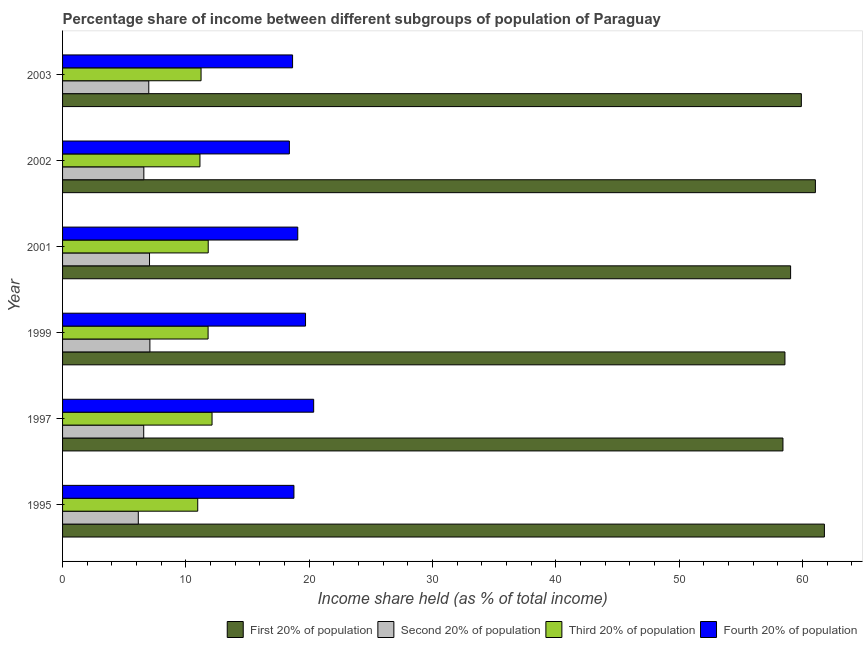How many different coloured bars are there?
Your answer should be compact. 4. Are the number of bars per tick equal to the number of legend labels?
Offer a terse response. Yes. Are the number of bars on each tick of the Y-axis equal?
Keep it short and to the point. Yes. How many bars are there on the 2nd tick from the top?
Provide a succinct answer. 4. What is the label of the 6th group of bars from the top?
Offer a very short reply. 1995. In how many cases, is the number of bars for a given year not equal to the number of legend labels?
Offer a terse response. 0. What is the share of the income held by fourth 20% of the population in 1995?
Your response must be concise. 18.76. Across all years, what is the maximum share of the income held by first 20% of the population?
Your response must be concise. 61.77. Across all years, what is the minimum share of the income held by fourth 20% of the population?
Your answer should be very brief. 18.39. In which year was the share of the income held by second 20% of the population minimum?
Your response must be concise. 1995. What is the total share of the income held by fourth 20% of the population in the graph?
Offer a very short reply. 114.93. What is the difference between the share of the income held by third 20% of the population in 1997 and that in 2001?
Make the answer very short. 0.31. What is the difference between the share of the income held by second 20% of the population in 2002 and the share of the income held by third 20% of the population in 2001?
Keep it short and to the point. -5.22. What is the average share of the income held by third 20% of the population per year?
Keep it short and to the point. 11.51. In the year 1997, what is the difference between the share of the income held by second 20% of the population and share of the income held by fourth 20% of the population?
Keep it short and to the point. -13.78. In how many years, is the share of the income held by second 20% of the population greater than 4 %?
Offer a very short reply. 6. What is the ratio of the share of the income held by third 20% of the population in 1999 to that in 2003?
Your answer should be compact. 1.05. Is the share of the income held by second 20% of the population in 2002 less than that in 2003?
Your response must be concise. Yes. What is the difference between the highest and the second highest share of the income held by first 20% of the population?
Keep it short and to the point. 0.73. What is the difference between the highest and the lowest share of the income held by third 20% of the population?
Your answer should be very brief. 1.16. In how many years, is the share of the income held by first 20% of the population greater than the average share of the income held by first 20% of the population taken over all years?
Your answer should be very brief. 3. What does the 1st bar from the top in 2002 represents?
Offer a terse response. Fourth 20% of population. What does the 3rd bar from the bottom in 1999 represents?
Keep it short and to the point. Third 20% of population. Is it the case that in every year, the sum of the share of the income held by first 20% of the population and share of the income held by second 20% of the population is greater than the share of the income held by third 20% of the population?
Make the answer very short. Yes. How many bars are there?
Give a very brief answer. 24. Are all the bars in the graph horizontal?
Your response must be concise. Yes. What is the difference between two consecutive major ticks on the X-axis?
Your response must be concise. 10. Where does the legend appear in the graph?
Ensure brevity in your answer.  Bottom right. How many legend labels are there?
Ensure brevity in your answer.  4. How are the legend labels stacked?
Provide a succinct answer. Horizontal. What is the title of the graph?
Provide a succinct answer. Percentage share of income between different subgroups of population of Paraguay. What is the label or title of the X-axis?
Your response must be concise. Income share held (as % of total income). What is the Income share held (as % of total income) in First 20% of population in 1995?
Your response must be concise. 61.77. What is the Income share held (as % of total income) of Second 20% of population in 1995?
Keep it short and to the point. 6.14. What is the Income share held (as % of total income) of Third 20% of population in 1995?
Your answer should be compact. 10.96. What is the Income share held (as % of total income) in Fourth 20% of population in 1995?
Your answer should be compact. 18.76. What is the Income share held (as % of total income) of First 20% of population in 1997?
Your answer should be very brief. 58.41. What is the Income share held (as % of total income) of Second 20% of population in 1997?
Your response must be concise. 6.58. What is the Income share held (as % of total income) in Third 20% of population in 1997?
Keep it short and to the point. 12.12. What is the Income share held (as % of total income) in Fourth 20% of population in 1997?
Provide a succinct answer. 20.36. What is the Income share held (as % of total income) of First 20% of population in 1999?
Provide a succinct answer. 58.57. What is the Income share held (as % of total income) of Second 20% of population in 1999?
Keep it short and to the point. 7.08. What is the Income share held (as % of total income) in First 20% of population in 2001?
Your answer should be compact. 59.03. What is the Income share held (as % of total income) of Second 20% of population in 2001?
Your answer should be very brief. 7.05. What is the Income share held (as % of total income) in Third 20% of population in 2001?
Provide a succinct answer. 11.81. What is the Income share held (as % of total income) in Fourth 20% of population in 2001?
Keep it short and to the point. 19.07. What is the Income share held (as % of total income) of First 20% of population in 2002?
Make the answer very short. 61.04. What is the Income share held (as % of total income) of Second 20% of population in 2002?
Your answer should be very brief. 6.59. What is the Income share held (as % of total income) in Third 20% of population in 2002?
Ensure brevity in your answer.  11.14. What is the Income share held (as % of total income) in Fourth 20% of population in 2002?
Give a very brief answer. 18.39. What is the Income share held (as % of total income) in First 20% of population in 2003?
Provide a succinct answer. 59.9. What is the Income share held (as % of total income) in Second 20% of population in 2003?
Keep it short and to the point. 6.99. What is the Income share held (as % of total income) of Third 20% of population in 2003?
Your answer should be very brief. 11.23. What is the Income share held (as % of total income) in Fourth 20% of population in 2003?
Keep it short and to the point. 18.65. Across all years, what is the maximum Income share held (as % of total income) of First 20% of population?
Ensure brevity in your answer.  61.77. Across all years, what is the maximum Income share held (as % of total income) of Second 20% of population?
Your answer should be compact. 7.08. Across all years, what is the maximum Income share held (as % of total income) of Third 20% of population?
Your answer should be very brief. 12.12. Across all years, what is the maximum Income share held (as % of total income) of Fourth 20% of population?
Offer a very short reply. 20.36. Across all years, what is the minimum Income share held (as % of total income) of First 20% of population?
Make the answer very short. 58.41. Across all years, what is the minimum Income share held (as % of total income) of Second 20% of population?
Your answer should be very brief. 6.14. Across all years, what is the minimum Income share held (as % of total income) in Third 20% of population?
Provide a succinct answer. 10.96. Across all years, what is the minimum Income share held (as % of total income) in Fourth 20% of population?
Your response must be concise. 18.39. What is the total Income share held (as % of total income) in First 20% of population in the graph?
Provide a succinct answer. 358.72. What is the total Income share held (as % of total income) of Second 20% of population in the graph?
Your answer should be very brief. 40.43. What is the total Income share held (as % of total income) in Third 20% of population in the graph?
Make the answer very short. 69.06. What is the total Income share held (as % of total income) of Fourth 20% of population in the graph?
Keep it short and to the point. 114.93. What is the difference between the Income share held (as % of total income) in First 20% of population in 1995 and that in 1997?
Provide a short and direct response. 3.36. What is the difference between the Income share held (as % of total income) of Second 20% of population in 1995 and that in 1997?
Ensure brevity in your answer.  -0.44. What is the difference between the Income share held (as % of total income) of Third 20% of population in 1995 and that in 1997?
Keep it short and to the point. -1.16. What is the difference between the Income share held (as % of total income) of First 20% of population in 1995 and that in 1999?
Offer a very short reply. 3.2. What is the difference between the Income share held (as % of total income) in Second 20% of population in 1995 and that in 1999?
Provide a succinct answer. -0.94. What is the difference between the Income share held (as % of total income) of Third 20% of population in 1995 and that in 1999?
Ensure brevity in your answer.  -0.84. What is the difference between the Income share held (as % of total income) in Fourth 20% of population in 1995 and that in 1999?
Your answer should be compact. -0.94. What is the difference between the Income share held (as % of total income) of First 20% of population in 1995 and that in 2001?
Offer a terse response. 2.74. What is the difference between the Income share held (as % of total income) in Second 20% of population in 1995 and that in 2001?
Keep it short and to the point. -0.91. What is the difference between the Income share held (as % of total income) of Third 20% of population in 1995 and that in 2001?
Your response must be concise. -0.85. What is the difference between the Income share held (as % of total income) of Fourth 20% of population in 1995 and that in 2001?
Offer a terse response. -0.31. What is the difference between the Income share held (as % of total income) of First 20% of population in 1995 and that in 2002?
Offer a very short reply. 0.73. What is the difference between the Income share held (as % of total income) of Second 20% of population in 1995 and that in 2002?
Offer a terse response. -0.45. What is the difference between the Income share held (as % of total income) of Third 20% of population in 1995 and that in 2002?
Make the answer very short. -0.18. What is the difference between the Income share held (as % of total income) in Fourth 20% of population in 1995 and that in 2002?
Keep it short and to the point. 0.37. What is the difference between the Income share held (as % of total income) of First 20% of population in 1995 and that in 2003?
Provide a succinct answer. 1.87. What is the difference between the Income share held (as % of total income) of Second 20% of population in 1995 and that in 2003?
Offer a terse response. -0.85. What is the difference between the Income share held (as % of total income) in Third 20% of population in 1995 and that in 2003?
Offer a very short reply. -0.27. What is the difference between the Income share held (as % of total income) in Fourth 20% of population in 1995 and that in 2003?
Your response must be concise. 0.11. What is the difference between the Income share held (as % of total income) of First 20% of population in 1997 and that in 1999?
Keep it short and to the point. -0.16. What is the difference between the Income share held (as % of total income) of Third 20% of population in 1997 and that in 1999?
Your response must be concise. 0.32. What is the difference between the Income share held (as % of total income) of Fourth 20% of population in 1997 and that in 1999?
Ensure brevity in your answer.  0.66. What is the difference between the Income share held (as % of total income) of First 20% of population in 1997 and that in 2001?
Your answer should be very brief. -0.62. What is the difference between the Income share held (as % of total income) of Second 20% of population in 1997 and that in 2001?
Keep it short and to the point. -0.47. What is the difference between the Income share held (as % of total income) in Third 20% of population in 1997 and that in 2001?
Your response must be concise. 0.31. What is the difference between the Income share held (as % of total income) of Fourth 20% of population in 1997 and that in 2001?
Provide a short and direct response. 1.29. What is the difference between the Income share held (as % of total income) of First 20% of population in 1997 and that in 2002?
Provide a succinct answer. -2.63. What is the difference between the Income share held (as % of total income) in Second 20% of population in 1997 and that in 2002?
Your answer should be compact. -0.01. What is the difference between the Income share held (as % of total income) in Third 20% of population in 1997 and that in 2002?
Offer a terse response. 0.98. What is the difference between the Income share held (as % of total income) in Fourth 20% of population in 1997 and that in 2002?
Offer a terse response. 1.97. What is the difference between the Income share held (as % of total income) in First 20% of population in 1997 and that in 2003?
Your response must be concise. -1.49. What is the difference between the Income share held (as % of total income) of Second 20% of population in 1997 and that in 2003?
Provide a succinct answer. -0.41. What is the difference between the Income share held (as % of total income) in Third 20% of population in 1997 and that in 2003?
Ensure brevity in your answer.  0.89. What is the difference between the Income share held (as % of total income) in Fourth 20% of population in 1997 and that in 2003?
Offer a terse response. 1.71. What is the difference between the Income share held (as % of total income) in First 20% of population in 1999 and that in 2001?
Your answer should be very brief. -0.46. What is the difference between the Income share held (as % of total income) in Third 20% of population in 1999 and that in 2001?
Your answer should be very brief. -0.01. What is the difference between the Income share held (as % of total income) in Fourth 20% of population in 1999 and that in 2001?
Your answer should be very brief. 0.63. What is the difference between the Income share held (as % of total income) in First 20% of population in 1999 and that in 2002?
Your answer should be very brief. -2.47. What is the difference between the Income share held (as % of total income) in Second 20% of population in 1999 and that in 2002?
Ensure brevity in your answer.  0.49. What is the difference between the Income share held (as % of total income) of Third 20% of population in 1999 and that in 2002?
Offer a very short reply. 0.66. What is the difference between the Income share held (as % of total income) in Fourth 20% of population in 1999 and that in 2002?
Your answer should be very brief. 1.31. What is the difference between the Income share held (as % of total income) in First 20% of population in 1999 and that in 2003?
Offer a very short reply. -1.33. What is the difference between the Income share held (as % of total income) in Second 20% of population in 1999 and that in 2003?
Provide a succinct answer. 0.09. What is the difference between the Income share held (as % of total income) in Third 20% of population in 1999 and that in 2003?
Provide a short and direct response. 0.57. What is the difference between the Income share held (as % of total income) in Fourth 20% of population in 1999 and that in 2003?
Ensure brevity in your answer.  1.05. What is the difference between the Income share held (as % of total income) in First 20% of population in 2001 and that in 2002?
Your answer should be very brief. -2.01. What is the difference between the Income share held (as % of total income) in Second 20% of population in 2001 and that in 2002?
Ensure brevity in your answer.  0.46. What is the difference between the Income share held (as % of total income) of Third 20% of population in 2001 and that in 2002?
Your answer should be compact. 0.67. What is the difference between the Income share held (as % of total income) of Fourth 20% of population in 2001 and that in 2002?
Provide a short and direct response. 0.68. What is the difference between the Income share held (as % of total income) of First 20% of population in 2001 and that in 2003?
Ensure brevity in your answer.  -0.87. What is the difference between the Income share held (as % of total income) in Second 20% of population in 2001 and that in 2003?
Keep it short and to the point. 0.06. What is the difference between the Income share held (as % of total income) of Third 20% of population in 2001 and that in 2003?
Your answer should be compact. 0.58. What is the difference between the Income share held (as % of total income) in Fourth 20% of population in 2001 and that in 2003?
Give a very brief answer. 0.42. What is the difference between the Income share held (as % of total income) in First 20% of population in 2002 and that in 2003?
Keep it short and to the point. 1.14. What is the difference between the Income share held (as % of total income) in Third 20% of population in 2002 and that in 2003?
Offer a terse response. -0.09. What is the difference between the Income share held (as % of total income) of Fourth 20% of population in 2002 and that in 2003?
Your answer should be very brief. -0.26. What is the difference between the Income share held (as % of total income) in First 20% of population in 1995 and the Income share held (as % of total income) in Second 20% of population in 1997?
Ensure brevity in your answer.  55.19. What is the difference between the Income share held (as % of total income) in First 20% of population in 1995 and the Income share held (as % of total income) in Third 20% of population in 1997?
Ensure brevity in your answer.  49.65. What is the difference between the Income share held (as % of total income) in First 20% of population in 1995 and the Income share held (as % of total income) in Fourth 20% of population in 1997?
Provide a short and direct response. 41.41. What is the difference between the Income share held (as % of total income) in Second 20% of population in 1995 and the Income share held (as % of total income) in Third 20% of population in 1997?
Offer a very short reply. -5.98. What is the difference between the Income share held (as % of total income) in Second 20% of population in 1995 and the Income share held (as % of total income) in Fourth 20% of population in 1997?
Provide a short and direct response. -14.22. What is the difference between the Income share held (as % of total income) in Third 20% of population in 1995 and the Income share held (as % of total income) in Fourth 20% of population in 1997?
Keep it short and to the point. -9.4. What is the difference between the Income share held (as % of total income) in First 20% of population in 1995 and the Income share held (as % of total income) in Second 20% of population in 1999?
Offer a terse response. 54.69. What is the difference between the Income share held (as % of total income) in First 20% of population in 1995 and the Income share held (as % of total income) in Third 20% of population in 1999?
Your response must be concise. 49.97. What is the difference between the Income share held (as % of total income) of First 20% of population in 1995 and the Income share held (as % of total income) of Fourth 20% of population in 1999?
Your answer should be very brief. 42.07. What is the difference between the Income share held (as % of total income) of Second 20% of population in 1995 and the Income share held (as % of total income) of Third 20% of population in 1999?
Keep it short and to the point. -5.66. What is the difference between the Income share held (as % of total income) in Second 20% of population in 1995 and the Income share held (as % of total income) in Fourth 20% of population in 1999?
Your answer should be compact. -13.56. What is the difference between the Income share held (as % of total income) of Third 20% of population in 1995 and the Income share held (as % of total income) of Fourth 20% of population in 1999?
Give a very brief answer. -8.74. What is the difference between the Income share held (as % of total income) in First 20% of population in 1995 and the Income share held (as % of total income) in Second 20% of population in 2001?
Your answer should be compact. 54.72. What is the difference between the Income share held (as % of total income) of First 20% of population in 1995 and the Income share held (as % of total income) of Third 20% of population in 2001?
Provide a succinct answer. 49.96. What is the difference between the Income share held (as % of total income) of First 20% of population in 1995 and the Income share held (as % of total income) of Fourth 20% of population in 2001?
Your answer should be very brief. 42.7. What is the difference between the Income share held (as % of total income) of Second 20% of population in 1995 and the Income share held (as % of total income) of Third 20% of population in 2001?
Your answer should be very brief. -5.67. What is the difference between the Income share held (as % of total income) in Second 20% of population in 1995 and the Income share held (as % of total income) in Fourth 20% of population in 2001?
Offer a terse response. -12.93. What is the difference between the Income share held (as % of total income) of Third 20% of population in 1995 and the Income share held (as % of total income) of Fourth 20% of population in 2001?
Give a very brief answer. -8.11. What is the difference between the Income share held (as % of total income) of First 20% of population in 1995 and the Income share held (as % of total income) of Second 20% of population in 2002?
Offer a terse response. 55.18. What is the difference between the Income share held (as % of total income) of First 20% of population in 1995 and the Income share held (as % of total income) of Third 20% of population in 2002?
Provide a short and direct response. 50.63. What is the difference between the Income share held (as % of total income) in First 20% of population in 1995 and the Income share held (as % of total income) in Fourth 20% of population in 2002?
Your answer should be very brief. 43.38. What is the difference between the Income share held (as % of total income) of Second 20% of population in 1995 and the Income share held (as % of total income) of Fourth 20% of population in 2002?
Make the answer very short. -12.25. What is the difference between the Income share held (as % of total income) in Third 20% of population in 1995 and the Income share held (as % of total income) in Fourth 20% of population in 2002?
Ensure brevity in your answer.  -7.43. What is the difference between the Income share held (as % of total income) of First 20% of population in 1995 and the Income share held (as % of total income) of Second 20% of population in 2003?
Provide a short and direct response. 54.78. What is the difference between the Income share held (as % of total income) in First 20% of population in 1995 and the Income share held (as % of total income) in Third 20% of population in 2003?
Your answer should be compact. 50.54. What is the difference between the Income share held (as % of total income) of First 20% of population in 1995 and the Income share held (as % of total income) of Fourth 20% of population in 2003?
Keep it short and to the point. 43.12. What is the difference between the Income share held (as % of total income) of Second 20% of population in 1995 and the Income share held (as % of total income) of Third 20% of population in 2003?
Make the answer very short. -5.09. What is the difference between the Income share held (as % of total income) of Second 20% of population in 1995 and the Income share held (as % of total income) of Fourth 20% of population in 2003?
Give a very brief answer. -12.51. What is the difference between the Income share held (as % of total income) in Third 20% of population in 1995 and the Income share held (as % of total income) in Fourth 20% of population in 2003?
Offer a very short reply. -7.69. What is the difference between the Income share held (as % of total income) of First 20% of population in 1997 and the Income share held (as % of total income) of Second 20% of population in 1999?
Offer a terse response. 51.33. What is the difference between the Income share held (as % of total income) of First 20% of population in 1997 and the Income share held (as % of total income) of Third 20% of population in 1999?
Keep it short and to the point. 46.61. What is the difference between the Income share held (as % of total income) of First 20% of population in 1997 and the Income share held (as % of total income) of Fourth 20% of population in 1999?
Keep it short and to the point. 38.71. What is the difference between the Income share held (as % of total income) of Second 20% of population in 1997 and the Income share held (as % of total income) of Third 20% of population in 1999?
Your response must be concise. -5.22. What is the difference between the Income share held (as % of total income) in Second 20% of population in 1997 and the Income share held (as % of total income) in Fourth 20% of population in 1999?
Offer a very short reply. -13.12. What is the difference between the Income share held (as % of total income) in Third 20% of population in 1997 and the Income share held (as % of total income) in Fourth 20% of population in 1999?
Make the answer very short. -7.58. What is the difference between the Income share held (as % of total income) in First 20% of population in 1997 and the Income share held (as % of total income) in Second 20% of population in 2001?
Ensure brevity in your answer.  51.36. What is the difference between the Income share held (as % of total income) of First 20% of population in 1997 and the Income share held (as % of total income) of Third 20% of population in 2001?
Provide a short and direct response. 46.6. What is the difference between the Income share held (as % of total income) of First 20% of population in 1997 and the Income share held (as % of total income) of Fourth 20% of population in 2001?
Provide a short and direct response. 39.34. What is the difference between the Income share held (as % of total income) of Second 20% of population in 1997 and the Income share held (as % of total income) of Third 20% of population in 2001?
Keep it short and to the point. -5.23. What is the difference between the Income share held (as % of total income) in Second 20% of population in 1997 and the Income share held (as % of total income) in Fourth 20% of population in 2001?
Offer a very short reply. -12.49. What is the difference between the Income share held (as % of total income) of Third 20% of population in 1997 and the Income share held (as % of total income) of Fourth 20% of population in 2001?
Make the answer very short. -6.95. What is the difference between the Income share held (as % of total income) of First 20% of population in 1997 and the Income share held (as % of total income) of Second 20% of population in 2002?
Keep it short and to the point. 51.82. What is the difference between the Income share held (as % of total income) in First 20% of population in 1997 and the Income share held (as % of total income) in Third 20% of population in 2002?
Make the answer very short. 47.27. What is the difference between the Income share held (as % of total income) of First 20% of population in 1997 and the Income share held (as % of total income) of Fourth 20% of population in 2002?
Offer a terse response. 40.02. What is the difference between the Income share held (as % of total income) in Second 20% of population in 1997 and the Income share held (as % of total income) in Third 20% of population in 2002?
Offer a very short reply. -4.56. What is the difference between the Income share held (as % of total income) of Second 20% of population in 1997 and the Income share held (as % of total income) of Fourth 20% of population in 2002?
Make the answer very short. -11.81. What is the difference between the Income share held (as % of total income) of Third 20% of population in 1997 and the Income share held (as % of total income) of Fourth 20% of population in 2002?
Ensure brevity in your answer.  -6.27. What is the difference between the Income share held (as % of total income) of First 20% of population in 1997 and the Income share held (as % of total income) of Second 20% of population in 2003?
Ensure brevity in your answer.  51.42. What is the difference between the Income share held (as % of total income) in First 20% of population in 1997 and the Income share held (as % of total income) in Third 20% of population in 2003?
Ensure brevity in your answer.  47.18. What is the difference between the Income share held (as % of total income) of First 20% of population in 1997 and the Income share held (as % of total income) of Fourth 20% of population in 2003?
Ensure brevity in your answer.  39.76. What is the difference between the Income share held (as % of total income) of Second 20% of population in 1997 and the Income share held (as % of total income) of Third 20% of population in 2003?
Keep it short and to the point. -4.65. What is the difference between the Income share held (as % of total income) in Second 20% of population in 1997 and the Income share held (as % of total income) in Fourth 20% of population in 2003?
Provide a succinct answer. -12.07. What is the difference between the Income share held (as % of total income) of Third 20% of population in 1997 and the Income share held (as % of total income) of Fourth 20% of population in 2003?
Give a very brief answer. -6.53. What is the difference between the Income share held (as % of total income) in First 20% of population in 1999 and the Income share held (as % of total income) in Second 20% of population in 2001?
Your response must be concise. 51.52. What is the difference between the Income share held (as % of total income) in First 20% of population in 1999 and the Income share held (as % of total income) in Third 20% of population in 2001?
Give a very brief answer. 46.76. What is the difference between the Income share held (as % of total income) in First 20% of population in 1999 and the Income share held (as % of total income) in Fourth 20% of population in 2001?
Make the answer very short. 39.5. What is the difference between the Income share held (as % of total income) of Second 20% of population in 1999 and the Income share held (as % of total income) of Third 20% of population in 2001?
Your answer should be compact. -4.73. What is the difference between the Income share held (as % of total income) of Second 20% of population in 1999 and the Income share held (as % of total income) of Fourth 20% of population in 2001?
Offer a very short reply. -11.99. What is the difference between the Income share held (as % of total income) of Third 20% of population in 1999 and the Income share held (as % of total income) of Fourth 20% of population in 2001?
Provide a short and direct response. -7.27. What is the difference between the Income share held (as % of total income) in First 20% of population in 1999 and the Income share held (as % of total income) in Second 20% of population in 2002?
Make the answer very short. 51.98. What is the difference between the Income share held (as % of total income) in First 20% of population in 1999 and the Income share held (as % of total income) in Third 20% of population in 2002?
Provide a short and direct response. 47.43. What is the difference between the Income share held (as % of total income) in First 20% of population in 1999 and the Income share held (as % of total income) in Fourth 20% of population in 2002?
Make the answer very short. 40.18. What is the difference between the Income share held (as % of total income) in Second 20% of population in 1999 and the Income share held (as % of total income) in Third 20% of population in 2002?
Give a very brief answer. -4.06. What is the difference between the Income share held (as % of total income) of Second 20% of population in 1999 and the Income share held (as % of total income) of Fourth 20% of population in 2002?
Ensure brevity in your answer.  -11.31. What is the difference between the Income share held (as % of total income) in Third 20% of population in 1999 and the Income share held (as % of total income) in Fourth 20% of population in 2002?
Make the answer very short. -6.59. What is the difference between the Income share held (as % of total income) in First 20% of population in 1999 and the Income share held (as % of total income) in Second 20% of population in 2003?
Provide a short and direct response. 51.58. What is the difference between the Income share held (as % of total income) in First 20% of population in 1999 and the Income share held (as % of total income) in Third 20% of population in 2003?
Ensure brevity in your answer.  47.34. What is the difference between the Income share held (as % of total income) in First 20% of population in 1999 and the Income share held (as % of total income) in Fourth 20% of population in 2003?
Ensure brevity in your answer.  39.92. What is the difference between the Income share held (as % of total income) in Second 20% of population in 1999 and the Income share held (as % of total income) in Third 20% of population in 2003?
Offer a terse response. -4.15. What is the difference between the Income share held (as % of total income) of Second 20% of population in 1999 and the Income share held (as % of total income) of Fourth 20% of population in 2003?
Make the answer very short. -11.57. What is the difference between the Income share held (as % of total income) of Third 20% of population in 1999 and the Income share held (as % of total income) of Fourth 20% of population in 2003?
Provide a succinct answer. -6.85. What is the difference between the Income share held (as % of total income) of First 20% of population in 2001 and the Income share held (as % of total income) of Second 20% of population in 2002?
Provide a succinct answer. 52.44. What is the difference between the Income share held (as % of total income) in First 20% of population in 2001 and the Income share held (as % of total income) in Third 20% of population in 2002?
Your response must be concise. 47.89. What is the difference between the Income share held (as % of total income) of First 20% of population in 2001 and the Income share held (as % of total income) of Fourth 20% of population in 2002?
Provide a succinct answer. 40.64. What is the difference between the Income share held (as % of total income) of Second 20% of population in 2001 and the Income share held (as % of total income) of Third 20% of population in 2002?
Ensure brevity in your answer.  -4.09. What is the difference between the Income share held (as % of total income) in Second 20% of population in 2001 and the Income share held (as % of total income) in Fourth 20% of population in 2002?
Offer a terse response. -11.34. What is the difference between the Income share held (as % of total income) in Third 20% of population in 2001 and the Income share held (as % of total income) in Fourth 20% of population in 2002?
Keep it short and to the point. -6.58. What is the difference between the Income share held (as % of total income) of First 20% of population in 2001 and the Income share held (as % of total income) of Second 20% of population in 2003?
Your answer should be compact. 52.04. What is the difference between the Income share held (as % of total income) in First 20% of population in 2001 and the Income share held (as % of total income) in Third 20% of population in 2003?
Give a very brief answer. 47.8. What is the difference between the Income share held (as % of total income) of First 20% of population in 2001 and the Income share held (as % of total income) of Fourth 20% of population in 2003?
Your response must be concise. 40.38. What is the difference between the Income share held (as % of total income) in Second 20% of population in 2001 and the Income share held (as % of total income) in Third 20% of population in 2003?
Your answer should be compact. -4.18. What is the difference between the Income share held (as % of total income) in Third 20% of population in 2001 and the Income share held (as % of total income) in Fourth 20% of population in 2003?
Keep it short and to the point. -6.84. What is the difference between the Income share held (as % of total income) in First 20% of population in 2002 and the Income share held (as % of total income) in Second 20% of population in 2003?
Your answer should be very brief. 54.05. What is the difference between the Income share held (as % of total income) in First 20% of population in 2002 and the Income share held (as % of total income) in Third 20% of population in 2003?
Ensure brevity in your answer.  49.81. What is the difference between the Income share held (as % of total income) in First 20% of population in 2002 and the Income share held (as % of total income) in Fourth 20% of population in 2003?
Offer a terse response. 42.39. What is the difference between the Income share held (as % of total income) of Second 20% of population in 2002 and the Income share held (as % of total income) of Third 20% of population in 2003?
Your answer should be very brief. -4.64. What is the difference between the Income share held (as % of total income) of Second 20% of population in 2002 and the Income share held (as % of total income) of Fourth 20% of population in 2003?
Offer a very short reply. -12.06. What is the difference between the Income share held (as % of total income) in Third 20% of population in 2002 and the Income share held (as % of total income) in Fourth 20% of population in 2003?
Offer a terse response. -7.51. What is the average Income share held (as % of total income) in First 20% of population per year?
Make the answer very short. 59.79. What is the average Income share held (as % of total income) in Second 20% of population per year?
Keep it short and to the point. 6.74. What is the average Income share held (as % of total income) in Third 20% of population per year?
Your answer should be very brief. 11.51. What is the average Income share held (as % of total income) in Fourth 20% of population per year?
Your response must be concise. 19.16. In the year 1995, what is the difference between the Income share held (as % of total income) in First 20% of population and Income share held (as % of total income) in Second 20% of population?
Provide a short and direct response. 55.63. In the year 1995, what is the difference between the Income share held (as % of total income) in First 20% of population and Income share held (as % of total income) in Third 20% of population?
Provide a short and direct response. 50.81. In the year 1995, what is the difference between the Income share held (as % of total income) in First 20% of population and Income share held (as % of total income) in Fourth 20% of population?
Offer a terse response. 43.01. In the year 1995, what is the difference between the Income share held (as % of total income) of Second 20% of population and Income share held (as % of total income) of Third 20% of population?
Make the answer very short. -4.82. In the year 1995, what is the difference between the Income share held (as % of total income) of Second 20% of population and Income share held (as % of total income) of Fourth 20% of population?
Offer a very short reply. -12.62. In the year 1995, what is the difference between the Income share held (as % of total income) in Third 20% of population and Income share held (as % of total income) in Fourth 20% of population?
Your answer should be compact. -7.8. In the year 1997, what is the difference between the Income share held (as % of total income) in First 20% of population and Income share held (as % of total income) in Second 20% of population?
Offer a very short reply. 51.83. In the year 1997, what is the difference between the Income share held (as % of total income) of First 20% of population and Income share held (as % of total income) of Third 20% of population?
Ensure brevity in your answer.  46.29. In the year 1997, what is the difference between the Income share held (as % of total income) of First 20% of population and Income share held (as % of total income) of Fourth 20% of population?
Offer a terse response. 38.05. In the year 1997, what is the difference between the Income share held (as % of total income) of Second 20% of population and Income share held (as % of total income) of Third 20% of population?
Your response must be concise. -5.54. In the year 1997, what is the difference between the Income share held (as % of total income) in Second 20% of population and Income share held (as % of total income) in Fourth 20% of population?
Provide a succinct answer. -13.78. In the year 1997, what is the difference between the Income share held (as % of total income) in Third 20% of population and Income share held (as % of total income) in Fourth 20% of population?
Offer a very short reply. -8.24. In the year 1999, what is the difference between the Income share held (as % of total income) of First 20% of population and Income share held (as % of total income) of Second 20% of population?
Keep it short and to the point. 51.49. In the year 1999, what is the difference between the Income share held (as % of total income) in First 20% of population and Income share held (as % of total income) in Third 20% of population?
Provide a succinct answer. 46.77. In the year 1999, what is the difference between the Income share held (as % of total income) of First 20% of population and Income share held (as % of total income) of Fourth 20% of population?
Offer a terse response. 38.87. In the year 1999, what is the difference between the Income share held (as % of total income) of Second 20% of population and Income share held (as % of total income) of Third 20% of population?
Give a very brief answer. -4.72. In the year 1999, what is the difference between the Income share held (as % of total income) of Second 20% of population and Income share held (as % of total income) of Fourth 20% of population?
Your answer should be very brief. -12.62. In the year 1999, what is the difference between the Income share held (as % of total income) of Third 20% of population and Income share held (as % of total income) of Fourth 20% of population?
Your answer should be very brief. -7.9. In the year 2001, what is the difference between the Income share held (as % of total income) in First 20% of population and Income share held (as % of total income) in Second 20% of population?
Provide a succinct answer. 51.98. In the year 2001, what is the difference between the Income share held (as % of total income) in First 20% of population and Income share held (as % of total income) in Third 20% of population?
Give a very brief answer. 47.22. In the year 2001, what is the difference between the Income share held (as % of total income) in First 20% of population and Income share held (as % of total income) in Fourth 20% of population?
Keep it short and to the point. 39.96. In the year 2001, what is the difference between the Income share held (as % of total income) in Second 20% of population and Income share held (as % of total income) in Third 20% of population?
Ensure brevity in your answer.  -4.76. In the year 2001, what is the difference between the Income share held (as % of total income) in Second 20% of population and Income share held (as % of total income) in Fourth 20% of population?
Your answer should be very brief. -12.02. In the year 2001, what is the difference between the Income share held (as % of total income) of Third 20% of population and Income share held (as % of total income) of Fourth 20% of population?
Give a very brief answer. -7.26. In the year 2002, what is the difference between the Income share held (as % of total income) of First 20% of population and Income share held (as % of total income) of Second 20% of population?
Your answer should be compact. 54.45. In the year 2002, what is the difference between the Income share held (as % of total income) of First 20% of population and Income share held (as % of total income) of Third 20% of population?
Offer a terse response. 49.9. In the year 2002, what is the difference between the Income share held (as % of total income) of First 20% of population and Income share held (as % of total income) of Fourth 20% of population?
Provide a succinct answer. 42.65. In the year 2002, what is the difference between the Income share held (as % of total income) in Second 20% of population and Income share held (as % of total income) in Third 20% of population?
Your response must be concise. -4.55. In the year 2002, what is the difference between the Income share held (as % of total income) in Third 20% of population and Income share held (as % of total income) in Fourth 20% of population?
Provide a short and direct response. -7.25. In the year 2003, what is the difference between the Income share held (as % of total income) in First 20% of population and Income share held (as % of total income) in Second 20% of population?
Offer a very short reply. 52.91. In the year 2003, what is the difference between the Income share held (as % of total income) of First 20% of population and Income share held (as % of total income) of Third 20% of population?
Your answer should be very brief. 48.67. In the year 2003, what is the difference between the Income share held (as % of total income) in First 20% of population and Income share held (as % of total income) in Fourth 20% of population?
Your answer should be very brief. 41.25. In the year 2003, what is the difference between the Income share held (as % of total income) in Second 20% of population and Income share held (as % of total income) in Third 20% of population?
Make the answer very short. -4.24. In the year 2003, what is the difference between the Income share held (as % of total income) in Second 20% of population and Income share held (as % of total income) in Fourth 20% of population?
Give a very brief answer. -11.66. In the year 2003, what is the difference between the Income share held (as % of total income) of Third 20% of population and Income share held (as % of total income) of Fourth 20% of population?
Give a very brief answer. -7.42. What is the ratio of the Income share held (as % of total income) in First 20% of population in 1995 to that in 1997?
Provide a succinct answer. 1.06. What is the ratio of the Income share held (as % of total income) in Second 20% of population in 1995 to that in 1997?
Keep it short and to the point. 0.93. What is the ratio of the Income share held (as % of total income) in Third 20% of population in 1995 to that in 1997?
Keep it short and to the point. 0.9. What is the ratio of the Income share held (as % of total income) in Fourth 20% of population in 1995 to that in 1997?
Your answer should be compact. 0.92. What is the ratio of the Income share held (as % of total income) in First 20% of population in 1995 to that in 1999?
Provide a succinct answer. 1.05. What is the ratio of the Income share held (as % of total income) of Second 20% of population in 1995 to that in 1999?
Your response must be concise. 0.87. What is the ratio of the Income share held (as % of total income) of Third 20% of population in 1995 to that in 1999?
Your answer should be compact. 0.93. What is the ratio of the Income share held (as % of total income) in Fourth 20% of population in 1995 to that in 1999?
Your answer should be compact. 0.95. What is the ratio of the Income share held (as % of total income) in First 20% of population in 1995 to that in 2001?
Ensure brevity in your answer.  1.05. What is the ratio of the Income share held (as % of total income) in Second 20% of population in 1995 to that in 2001?
Ensure brevity in your answer.  0.87. What is the ratio of the Income share held (as % of total income) of Third 20% of population in 1995 to that in 2001?
Make the answer very short. 0.93. What is the ratio of the Income share held (as % of total income) in Fourth 20% of population in 1995 to that in 2001?
Your answer should be compact. 0.98. What is the ratio of the Income share held (as % of total income) of Second 20% of population in 1995 to that in 2002?
Offer a terse response. 0.93. What is the ratio of the Income share held (as % of total income) in Third 20% of population in 1995 to that in 2002?
Your answer should be compact. 0.98. What is the ratio of the Income share held (as % of total income) in Fourth 20% of population in 1995 to that in 2002?
Your answer should be very brief. 1.02. What is the ratio of the Income share held (as % of total income) of First 20% of population in 1995 to that in 2003?
Keep it short and to the point. 1.03. What is the ratio of the Income share held (as % of total income) in Second 20% of population in 1995 to that in 2003?
Your response must be concise. 0.88. What is the ratio of the Income share held (as % of total income) of Third 20% of population in 1995 to that in 2003?
Your answer should be very brief. 0.98. What is the ratio of the Income share held (as % of total income) of Fourth 20% of population in 1995 to that in 2003?
Your response must be concise. 1.01. What is the ratio of the Income share held (as % of total income) in Second 20% of population in 1997 to that in 1999?
Give a very brief answer. 0.93. What is the ratio of the Income share held (as % of total income) of Third 20% of population in 1997 to that in 1999?
Your response must be concise. 1.03. What is the ratio of the Income share held (as % of total income) in Fourth 20% of population in 1997 to that in 1999?
Your response must be concise. 1.03. What is the ratio of the Income share held (as % of total income) in Third 20% of population in 1997 to that in 2001?
Your response must be concise. 1.03. What is the ratio of the Income share held (as % of total income) in Fourth 20% of population in 1997 to that in 2001?
Provide a succinct answer. 1.07. What is the ratio of the Income share held (as % of total income) in First 20% of population in 1997 to that in 2002?
Keep it short and to the point. 0.96. What is the ratio of the Income share held (as % of total income) of Second 20% of population in 1997 to that in 2002?
Provide a succinct answer. 1. What is the ratio of the Income share held (as % of total income) of Third 20% of population in 1997 to that in 2002?
Provide a succinct answer. 1.09. What is the ratio of the Income share held (as % of total income) of Fourth 20% of population in 1997 to that in 2002?
Provide a short and direct response. 1.11. What is the ratio of the Income share held (as % of total income) of First 20% of population in 1997 to that in 2003?
Give a very brief answer. 0.98. What is the ratio of the Income share held (as % of total income) in Second 20% of population in 1997 to that in 2003?
Keep it short and to the point. 0.94. What is the ratio of the Income share held (as % of total income) of Third 20% of population in 1997 to that in 2003?
Provide a short and direct response. 1.08. What is the ratio of the Income share held (as % of total income) of Fourth 20% of population in 1997 to that in 2003?
Ensure brevity in your answer.  1.09. What is the ratio of the Income share held (as % of total income) of Third 20% of population in 1999 to that in 2001?
Keep it short and to the point. 1. What is the ratio of the Income share held (as % of total income) of Fourth 20% of population in 1999 to that in 2001?
Provide a succinct answer. 1.03. What is the ratio of the Income share held (as % of total income) in First 20% of population in 1999 to that in 2002?
Your answer should be very brief. 0.96. What is the ratio of the Income share held (as % of total income) in Second 20% of population in 1999 to that in 2002?
Provide a succinct answer. 1.07. What is the ratio of the Income share held (as % of total income) of Third 20% of population in 1999 to that in 2002?
Make the answer very short. 1.06. What is the ratio of the Income share held (as % of total income) in Fourth 20% of population in 1999 to that in 2002?
Your answer should be compact. 1.07. What is the ratio of the Income share held (as % of total income) of First 20% of population in 1999 to that in 2003?
Keep it short and to the point. 0.98. What is the ratio of the Income share held (as % of total income) in Second 20% of population in 1999 to that in 2003?
Keep it short and to the point. 1.01. What is the ratio of the Income share held (as % of total income) of Third 20% of population in 1999 to that in 2003?
Your answer should be compact. 1.05. What is the ratio of the Income share held (as % of total income) of Fourth 20% of population in 1999 to that in 2003?
Offer a terse response. 1.06. What is the ratio of the Income share held (as % of total income) in First 20% of population in 2001 to that in 2002?
Offer a terse response. 0.97. What is the ratio of the Income share held (as % of total income) in Second 20% of population in 2001 to that in 2002?
Offer a terse response. 1.07. What is the ratio of the Income share held (as % of total income) of Third 20% of population in 2001 to that in 2002?
Your answer should be compact. 1.06. What is the ratio of the Income share held (as % of total income) of Fourth 20% of population in 2001 to that in 2002?
Your answer should be very brief. 1.04. What is the ratio of the Income share held (as % of total income) of First 20% of population in 2001 to that in 2003?
Provide a short and direct response. 0.99. What is the ratio of the Income share held (as % of total income) in Second 20% of population in 2001 to that in 2003?
Offer a very short reply. 1.01. What is the ratio of the Income share held (as % of total income) in Third 20% of population in 2001 to that in 2003?
Offer a very short reply. 1.05. What is the ratio of the Income share held (as % of total income) in Fourth 20% of population in 2001 to that in 2003?
Your answer should be very brief. 1.02. What is the ratio of the Income share held (as % of total income) in First 20% of population in 2002 to that in 2003?
Ensure brevity in your answer.  1.02. What is the ratio of the Income share held (as % of total income) in Second 20% of population in 2002 to that in 2003?
Offer a very short reply. 0.94. What is the ratio of the Income share held (as % of total income) in Third 20% of population in 2002 to that in 2003?
Offer a very short reply. 0.99. What is the ratio of the Income share held (as % of total income) in Fourth 20% of population in 2002 to that in 2003?
Ensure brevity in your answer.  0.99. What is the difference between the highest and the second highest Income share held (as % of total income) of First 20% of population?
Offer a very short reply. 0.73. What is the difference between the highest and the second highest Income share held (as % of total income) in Second 20% of population?
Provide a short and direct response. 0.03. What is the difference between the highest and the second highest Income share held (as % of total income) in Third 20% of population?
Keep it short and to the point. 0.31. What is the difference between the highest and the second highest Income share held (as % of total income) in Fourth 20% of population?
Give a very brief answer. 0.66. What is the difference between the highest and the lowest Income share held (as % of total income) of First 20% of population?
Your response must be concise. 3.36. What is the difference between the highest and the lowest Income share held (as % of total income) of Second 20% of population?
Your answer should be compact. 0.94. What is the difference between the highest and the lowest Income share held (as % of total income) of Third 20% of population?
Offer a terse response. 1.16. What is the difference between the highest and the lowest Income share held (as % of total income) in Fourth 20% of population?
Offer a terse response. 1.97. 